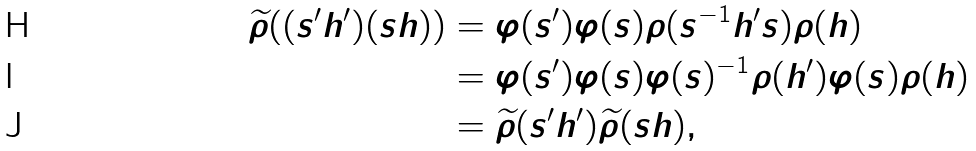<formula> <loc_0><loc_0><loc_500><loc_500>\widetilde { \rho } ( ( s ^ { \prime } h ^ { \prime } ) ( s h ) ) & = \varphi ( s ^ { \prime } ) \varphi ( s ) \rho ( s ^ { - 1 } h ^ { \prime } s ) \rho ( h ) \\ & = \varphi ( s ^ { \prime } ) \varphi ( s ) \varphi ( s ) ^ { - 1 } \rho ( h ^ { \prime } ) \varphi ( s ) \rho ( h ) \\ & = \widetilde { \rho } ( s ^ { \prime } h ^ { \prime } ) \widetilde { \rho } ( s h ) ,</formula> 